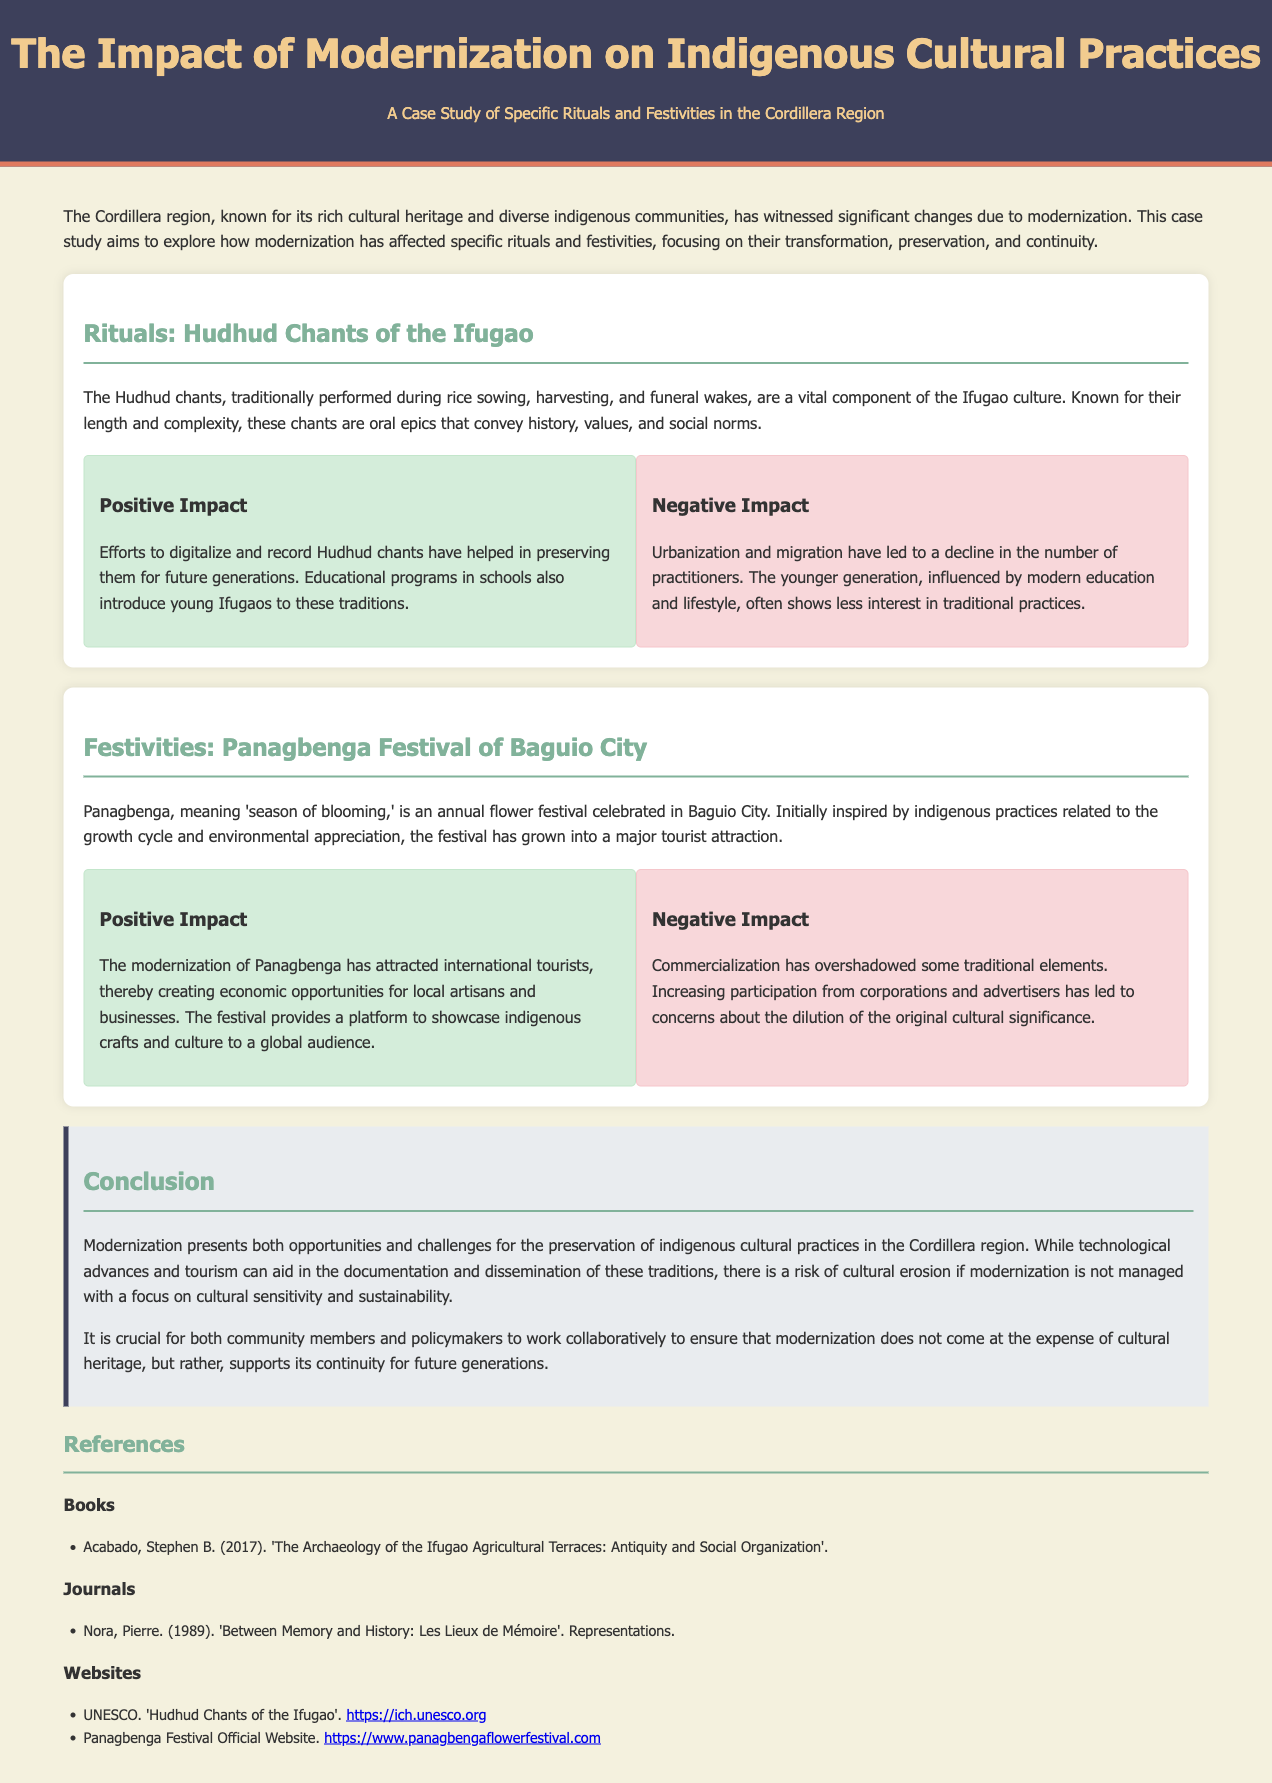What is the focus of the case study? The case study aims to explore how modernization has affected specific rituals and festivities, focusing on their transformation, preservation, and continuity.
Answer: Modernization's impact on rituals and festivities What is the length of the Hudhud chants? The Hudhud chants are known for their length and complexity.
Answer: Length and complexity What does "Panagbenga" mean? Panagbenga means 'season of blooming'.
Answer: 'Season of blooming' What positive impact has the Hudhud chants experienced? Efforts to digitalize and record Hudhud chants have helped in preserving them for future generations.
Answer: Preservation through digitalization What challenge does urbanization create for the Hudhud chants? Urbanization and migration have led to a decline in the number of practitioners.
Answer: Decline in practitioners What is a significant economic opportunity from the Panagbenga Festival? The modernization of Panagbenga has attracted international tourists, creating economic opportunities for local artisans and businesses.
Answer: Economic opportunities for local artisans What concern is raised about commercialization in festivals? Increasing participation from corporations and advertisers has led to concerns about the dilution of the original cultural significance.
Answer: Dilution of cultural significance What is crucial for community members and policymakers regarding modernization? It is crucial for both community members and policymakers to work collaboratively to ensure that modernization does not come at the expense of cultural heritage.
Answer: Collaboration to protect cultural heritage How are educational programs contributing to cultural preservation? Educational programs in schools introduce young Ifugaos to these traditions.
Answer: Introducing traditions in schools 